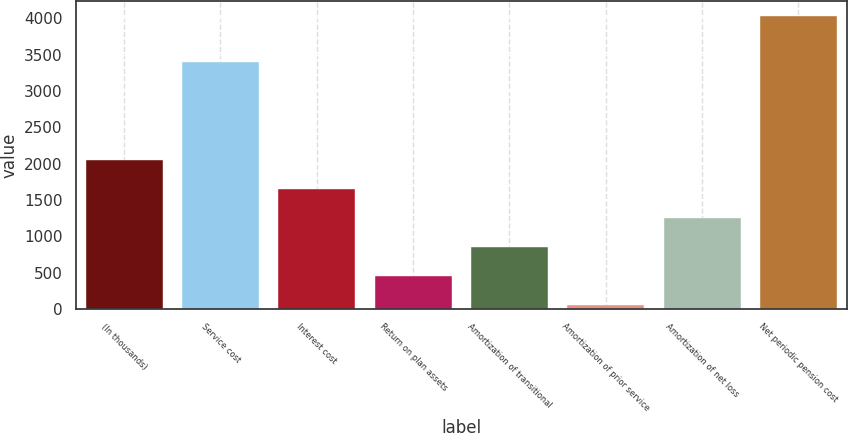<chart> <loc_0><loc_0><loc_500><loc_500><bar_chart><fcel>(In thousands)<fcel>Service cost<fcel>Interest cost<fcel>Return on plan assets<fcel>Amortization of transitional<fcel>Amortization of prior service<fcel>Amortization of net loss<fcel>Net periodic pension cost<nl><fcel>2044.5<fcel>3399<fcel>1647.2<fcel>455.3<fcel>852.6<fcel>58<fcel>1249.9<fcel>4031<nl></chart> 